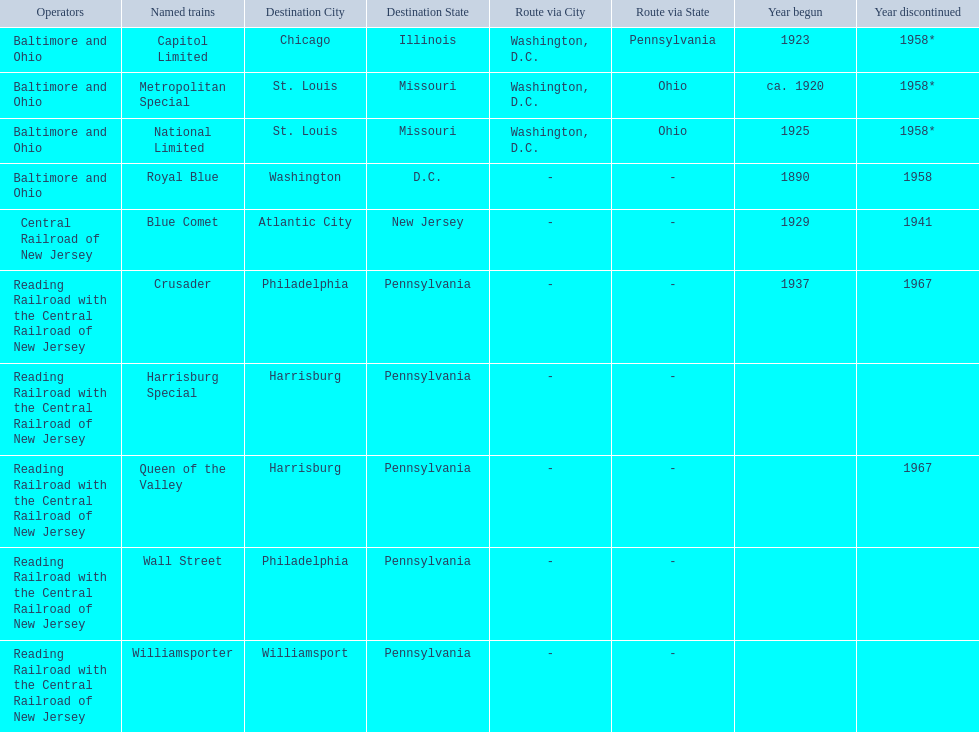Which of the trains are operated by reading railroad with the central railroad of new jersey? Crusader, Harrisburg Special, Queen of the Valley, Wall Street, Williamsporter. Of these trains, which of them had a destination of philadelphia, pennsylvania? Crusader, Wall Street. Out of these two trains, which one is discontinued? Crusader. 